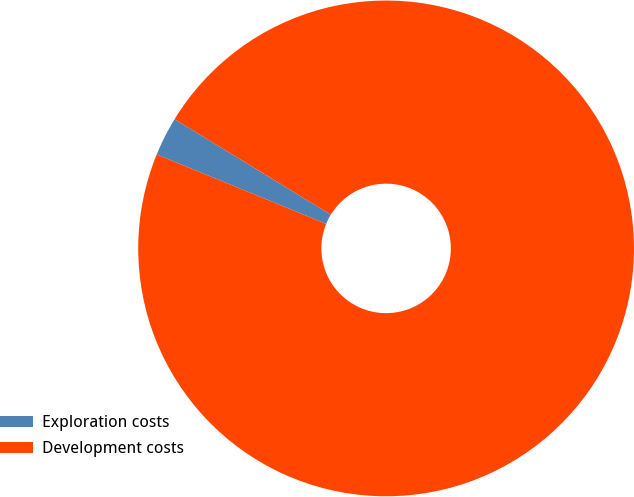Convert chart. <chart><loc_0><loc_0><loc_500><loc_500><pie_chart><fcel>Exploration costs<fcel>Development costs<nl><fcel>2.54%<fcel>97.46%<nl></chart> 